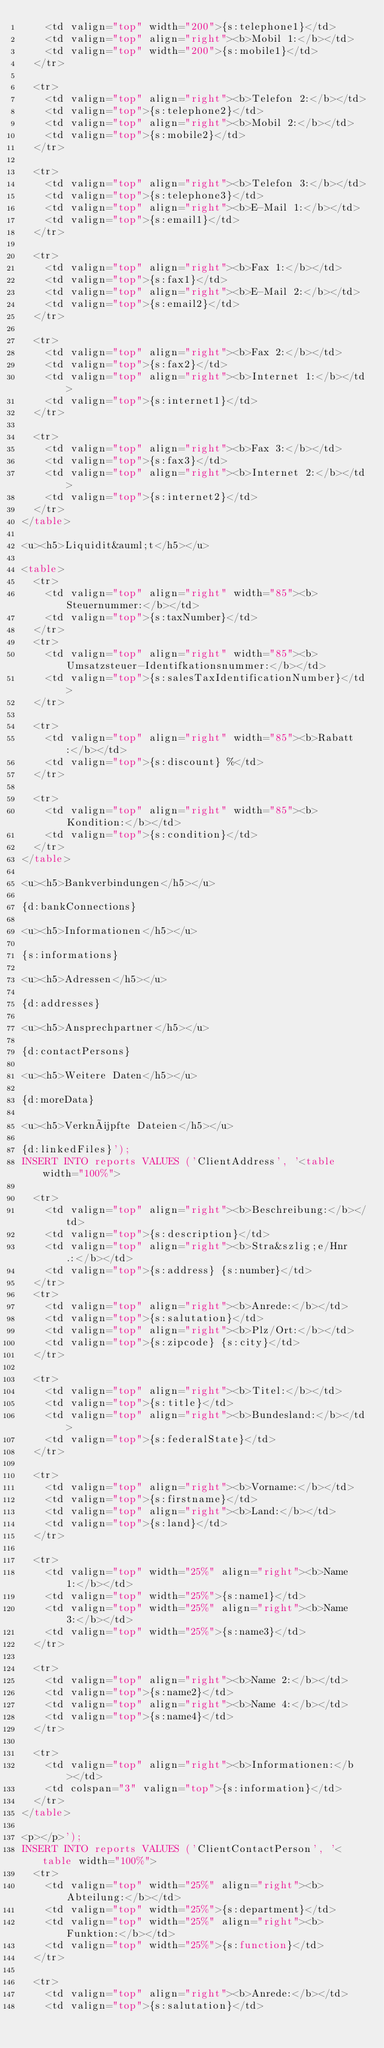Convert code to text. <code><loc_0><loc_0><loc_500><loc_500><_SQL_>		<td valign="top" width="200">{s:telephone1}</td>
		<td valign="top" align="right"><b>Mobil 1:</b></td>
		<td valign="top" width="200">{s:mobile1}</td>
	</tr>

	<tr>
		<td valign="top" align="right"><b>Telefon 2:</b></td>
		<td valign="top">{s:telephone2}</td>
		<td valign="top" align="right"><b>Mobil 2:</b></td>
		<td valign="top">{s:mobile2}</td>
	</tr>

	<tr>
		<td valign="top" align="right"><b>Telefon 3:</b></td>
		<td valign="top">{s:telephone3}</td>
		<td valign="top" align="right"><b>E-Mail 1:</b></td>
		<td valign="top">{s:email1}</td>
	</tr>

	<tr>
		<td valign="top" align="right"><b>Fax 1:</b></td>
		<td valign="top">{s:fax1}</td>
		<td valign="top" align="right"><b>E-Mail 2:</b></td>
		<td valign="top">{s:email2}</td>
	</tr>

	<tr>
		<td valign="top" align="right"><b>Fax 2:</b></td>
		<td valign="top">{s:fax2}</td>
		<td valign="top" align="right"><b>Internet 1:</b></td>
		<td valign="top">{s:internet1}</td>
	</tr>

	<tr>
		<td valign="top" align="right"><b>Fax 3:</b></td>
		<td valign="top">{s:fax3}</td>
		<td valign="top" align="right"><b>Internet 2:</b></td>
		<td valign="top">{s:internet2}</td>
	</tr>
</table>

<u><h5>Liquidit&auml;t</h5></u>

<table>
	<tr>
		<td valign="top" align="right" width="85"><b>Steuernummer:</b></td>
		<td valign="top">{s:taxNumber}</td>
	</tr>
	<tr>
		<td valign="top" align="right" width="85"><b>Umsatzsteuer-Identifkationsnummer:</b></td>
		<td valign="top">{s:salesTaxIdentificationNumber}</td>
	</tr>

	<tr>
		<td valign="top" align="right" width="85"><b>Rabatt:</b></td>
		<td valign="top">{s:discount} %</td>
	</tr>

	<tr>
		<td valign="top" align="right" width="85"><b>Kondition:</b></td>
		<td valign="top">{s:condition}</td>
	</tr>
</table>

<u><h5>Bankverbindungen</h5></u>

{d:bankConnections}

<u><h5>Informationen</h5></u>

{s:informations}

<u><h5>Adressen</h5></u>

{d:addresses}

<u><h5>Ansprechpartner</h5></u>

{d:contactPersons}

<u><h5>Weitere Daten</h5></u>

{d:moreData}

<u><h5>Verknüpfte Dateien</h5></u>

{d:linkedFiles}');
INSERT INTO reports VALUES ('ClientAddress', '<table width="100%">

	<tr>
		<td valign="top" align="right"><b>Beschreibung:</b></td>
		<td valign="top">{s:description}</td>
		<td valign="top" align="right"><b>Stra&szlig;e/Hnr.:</b></td>
		<td valign="top">{s:address} {s:number}</td>
	</tr>
	<tr>
		<td valign="top" align="right"><b>Anrede:</b></td>
		<td valign="top">{s:salutation}</td>
		<td valign="top" align="right"><b>Plz/Ort:</b></td>
		<td valign="top">{s:zipcode} {s:city}</td>
	</tr>

	<tr>
		<td valign="top" align="right"><b>Titel:</b></td>
		<td valign="top">{s:title}</td>
		<td valign="top" align="right"><b>Bundesland:</b></td>
		<td valign="top">{s:federalState}</td>
	</tr>

	<tr>
		<td valign="top" align="right"><b>Vorname:</b></td>
		<td valign="top">{s:firstname}</td>
		<td valign="top" align="right"><b>Land:</b></td>
		<td valign="top">{s:land}</td>
	</tr>

	<tr>
		<td valign="top" width="25%" align="right"><b>Name 1:</b></td>
		<td valign="top" width="25%">{s:name1}</td>
		<td valign="top" width="25%" align="right"><b>Name 3:</b></td>
		<td valign="top" width="25%">{s:name3}</td>
	</tr>

	<tr>
		<td valign="top" align="right"><b>Name 2:</b></td>
		<td valign="top">{s:name2}</td>
		<td valign="top" align="right"><b>Name 4:</b></td>
		<td valign="top">{s:name4}</td>
	</tr>

	<tr>
		<td valign="top" align="right"><b>Informationen:</b></td>
		<td colspan="3" valign="top">{s:information}</td>
	</tr>
</table>

<p></p>');
INSERT INTO reports VALUES ('ClientContactPerson', '<table width="100%">
	<tr>
		<td valign="top" width="25%" align="right"><b>Abteilung:</b></td>
		<td valign="top" width="25%">{s:department}</td>
		<td valign="top" width="25%" align="right"><b>Funktion:</b></td>
		<td valign="top" width="25%">{s:function}</td>
	</tr>

	<tr>
		<td valign="top" align="right"><b>Anrede:</b></td>
		<td valign="top">{s:salutation}</td></code> 